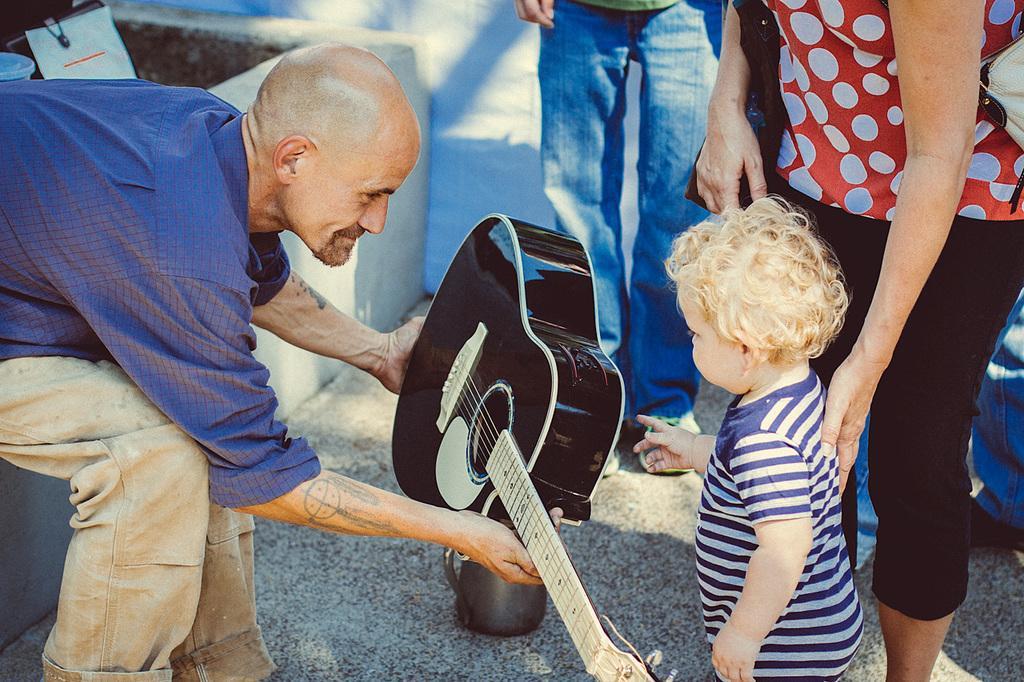Describe this image in one or two sentences. This image is clicked on the road. There are few people in this image. To the left there is a man sitting, wearing a blue shirt and holding a guitar. To the right, there is a kid wearing a blue and white t-shirt. Behind him there is a woman standing. She is wearing a red shirt and black pant. 